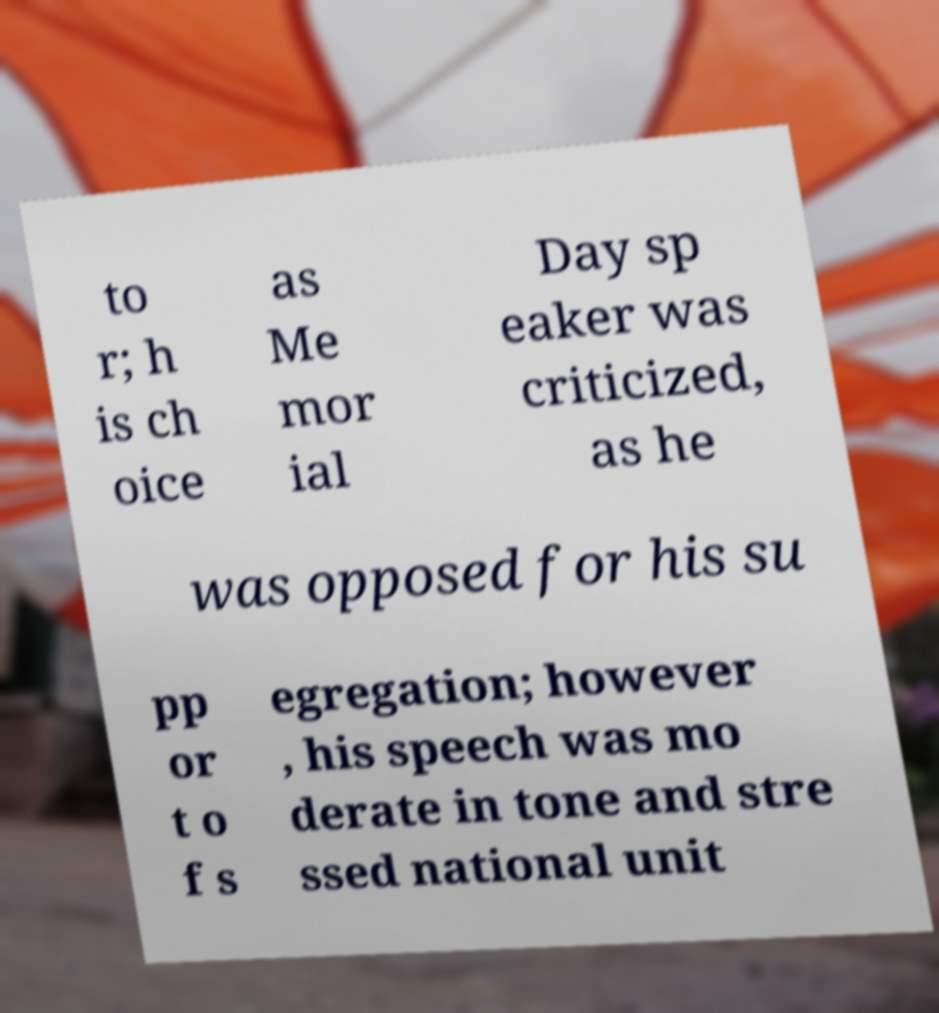Can you read and provide the text displayed in the image?This photo seems to have some interesting text. Can you extract and type it out for me? to r; h is ch oice as Me mor ial Day sp eaker was criticized, as he was opposed for his su pp or t o f s egregation; however , his speech was mo derate in tone and stre ssed national unit 